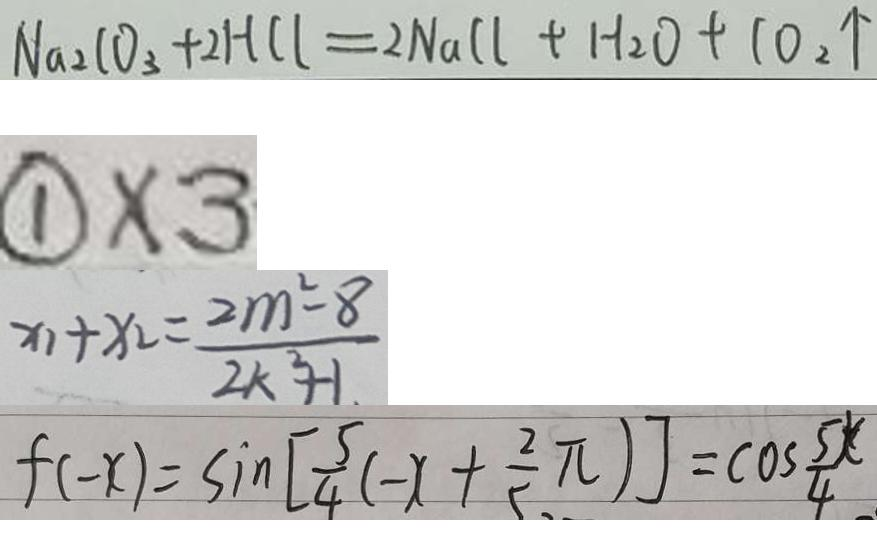<formula> <loc_0><loc_0><loc_500><loc_500>N a _ { 2 } C O _ { 3 } + 2 H C l = 2 N a C l + H _ { 2 } O + 1 0 _ { 2 } \uparrow 
 \textcircled { 1 } \times 3 
 x _ { 1 } + x _ { 2 } = \frac { 2 m ^ { 2 } - 8 } { 2 k ^ { 2 } + 1 . } 
 f ( - x ) = \sin [ \frac { 5 } { 4 } ( - x + \frac { 2 } { 5 } \pi ) ] = \cos \frac { 5 x } { 4 }</formula> 